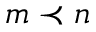Convert formula to latex. <formula><loc_0><loc_0><loc_500><loc_500>m \prec n</formula> 